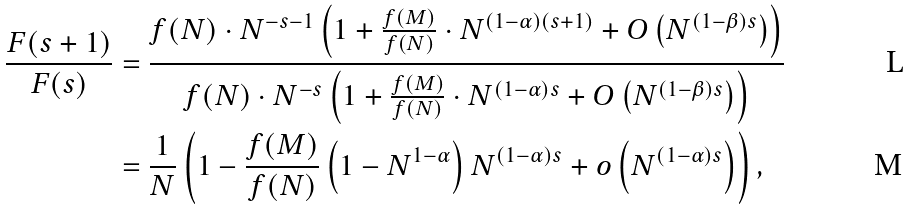<formula> <loc_0><loc_0><loc_500><loc_500>\frac { F ( s + 1 ) } { F ( s ) } & = \frac { f ( N ) \cdot N ^ { - s - 1 } \left ( 1 + \frac { f ( M ) } { f ( N ) } \cdot N ^ { ( 1 - \alpha ) ( s + 1 ) } + O \left ( N ^ { ( 1 - \beta ) s } \right ) \right ) } { f ( N ) \cdot N ^ { - s } \left ( 1 + \frac { f ( M ) } { f ( N ) } \cdot N ^ { ( 1 - \alpha ) s } + O \left ( N ^ { ( 1 - \beta ) s } \right ) \right ) } \\ & = \frac { 1 } { N } \left ( 1 - \frac { f ( M ) } { f ( N ) } \left ( 1 - N ^ { 1 - \alpha } \right ) N ^ { ( 1 - \alpha ) s } + o \left ( N ^ { ( 1 - \alpha ) s } \right ) \right ) ,</formula> 